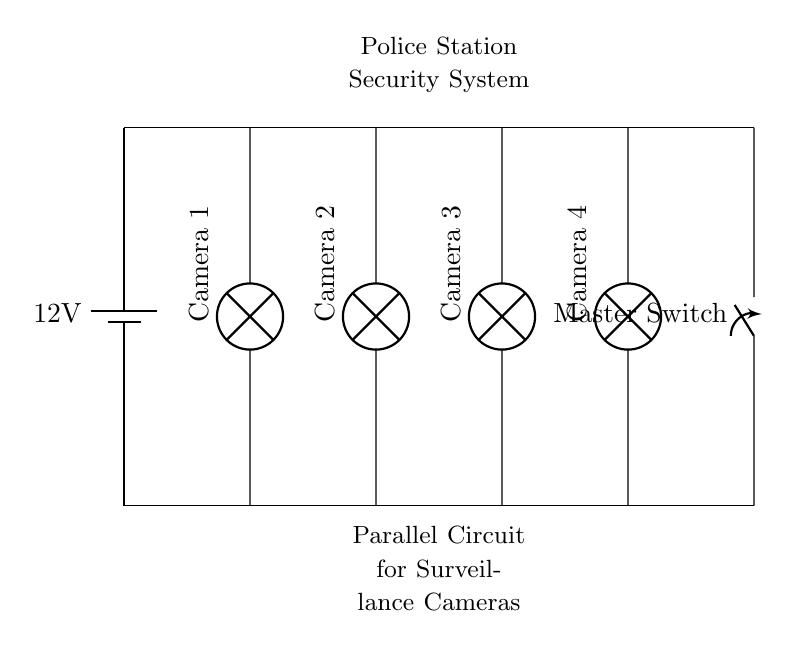What is the voltage of the power supply? The power supply shown in the circuit diagram is marked with a label indicating its voltage. The label reads "12V", which is the voltage provided to the circuit.
Answer: 12 volts How many cameras are in this circuit? By examining the circuit diagram, you can count the number of lamps labeled as "Camera" connected in parallel. There are four lamps numbered Camera 1 to Camera 4.
Answer: Four What is the purpose of the master switch? The master switch is designed to control the entire circuit, allowing the operator to turn on or off the power to all connected components, in this case, the surveillance cameras.
Answer: To control power What would happen if one camera fails? In a parallel circuit, if one component (like a camera) fails or is disconnected, the others continue to function normally because they have separate paths for current flow. Therefore, the remaining cameras will still operate.
Answer: The others remain functional What is the potential difference across each camera? In a parallel circuit, each component receives the same voltage as the power supply. Since the power supply is 12V, each camera sees a voltage of 12V across it.
Answer: 12 volts What type of circuit is this? The diagram explicitly shows multiple cameras connected in parallel, where each camera is connected separately to the same power source. Therefore, the type of circuit illustrated is a parallel circuit.
Answer: Parallel circuit 